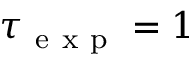Convert formula to latex. <formula><loc_0><loc_0><loc_500><loc_500>\tau _ { e x p } = 1</formula> 